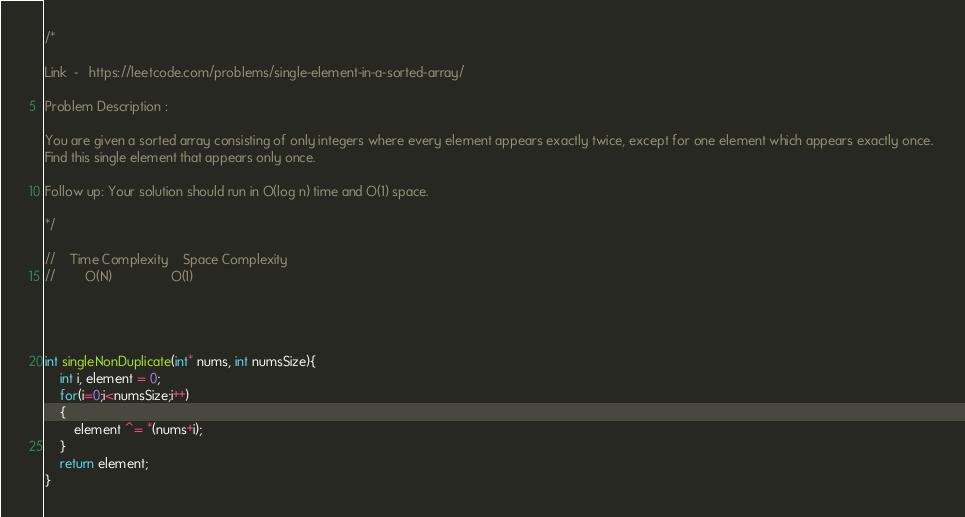<code> <loc_0><loc_0><loc_500><loc_500><_C_>/*

Link  -   https://leetcode.com/problems/single-element-in-a-sorted-array/

Problem Description :

You are given a sorted array consisting of only integers where every element appears exactly twice, except for one element which appears exactly once. 
Find this single element that appears only once.

Follow up: Your solution should run in O(log n) time and O(1) space.

*/

//    Time Complexity    Space Complexity
//        O(N)                O(1)




int singleNonDuplicate(int* nums, int numsSize){
    int i, element = 0;
    for(i=0;i<numsSize;i++)
    {
        element ^= *(nums+i);
    }
    return element;
}


</code> 